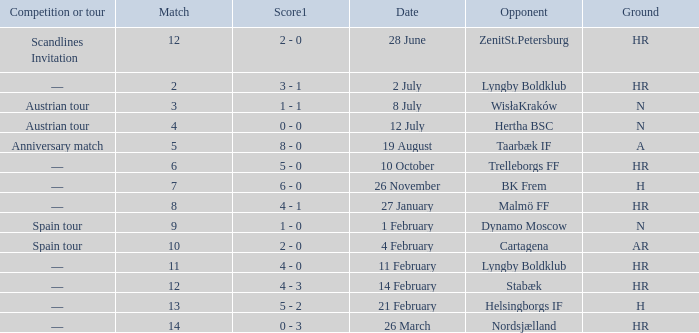In which competition or tour was nordsjælland the opponent with a hr Ground? —. 